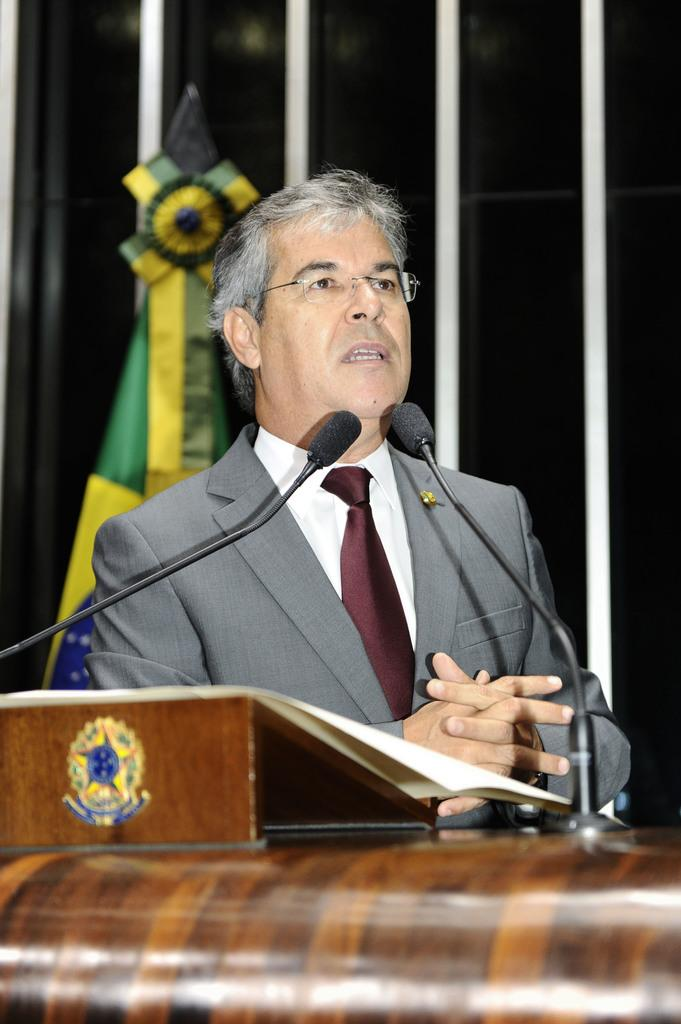What is the man standing near in the image? The man is standing near a speaker stand in the image. What is on the speaker stand? The speaker stand contains papers and mics with stands. Can you describe the flag in the image? The flag is on the backside of the image. What type of rice is being cooked in the image? There is no rice present in the image; it features a man standing near a speaker stand with papers and mics. How many geese are flying in the image? There are no geese present in the image. 